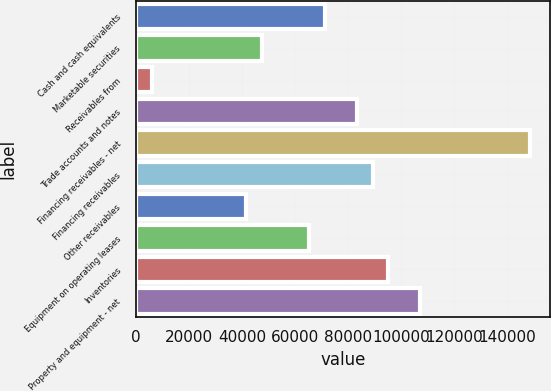Convert chart to OTSL. <chart><loc_0><loc_0><loc_500><loc_500><bar_chart><fcel>Cash and cash equivalents<fcel>Marketable securities<fcel>Receivables from<fcel>Trade accounts and notes<fcel>Financing receivables - net<fcel>Financing receivables<fcel>Other receivables<fcel>Equipment on operating leases<fcel>Inventories<fcel>Property and equipment - net<nl><fcel>71425.2<fcel>47617.4<fcel>5953.84<fcel>83329.1<fcel>148800<fcel>89281<fcel>41665.5<fcel>65473.2<fcel>95232.9<fcel>107137<nl></chart> 